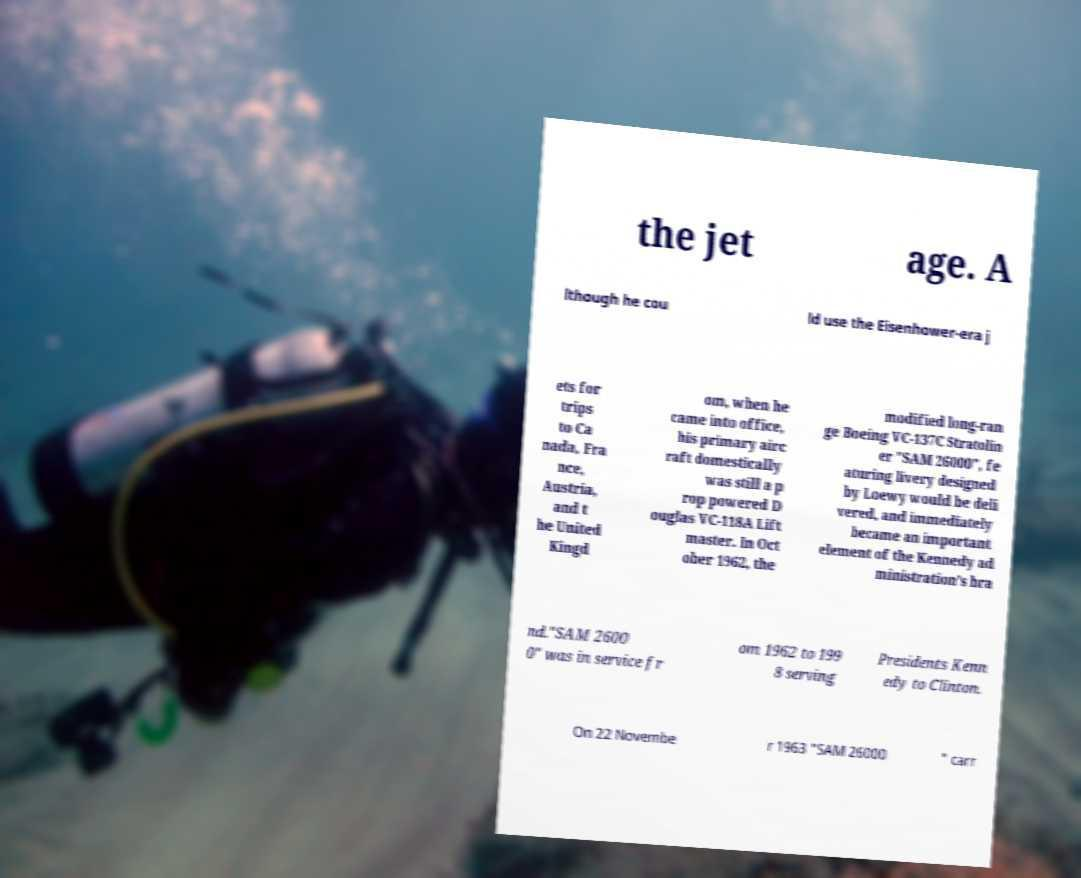Could you extract and type out the text from this image? the jet age. A lthough he cou ld use the Eisenhower-era j ets for trips to Ca nada, Fra nce, Austria, and t he United Kingd om, when he came into office, his primary airc raft domestically was still a p rop powered D ouglas VC-118A Lift master. In Oct ober 1962, the modified long-ran ge Boeing VC-137C Stratolin er "SAM 26000", fe aturing livery designed by Loewy would be deli vered, and immediately became an important element of the Kennedy ad ministration’s bra nd."SAM 2600 0" was in service fr om 1962 to 199 8 serving Presidents Kenn edy to Clinton. On 22 Novembe r 1963 "SAM 26000 " carr 